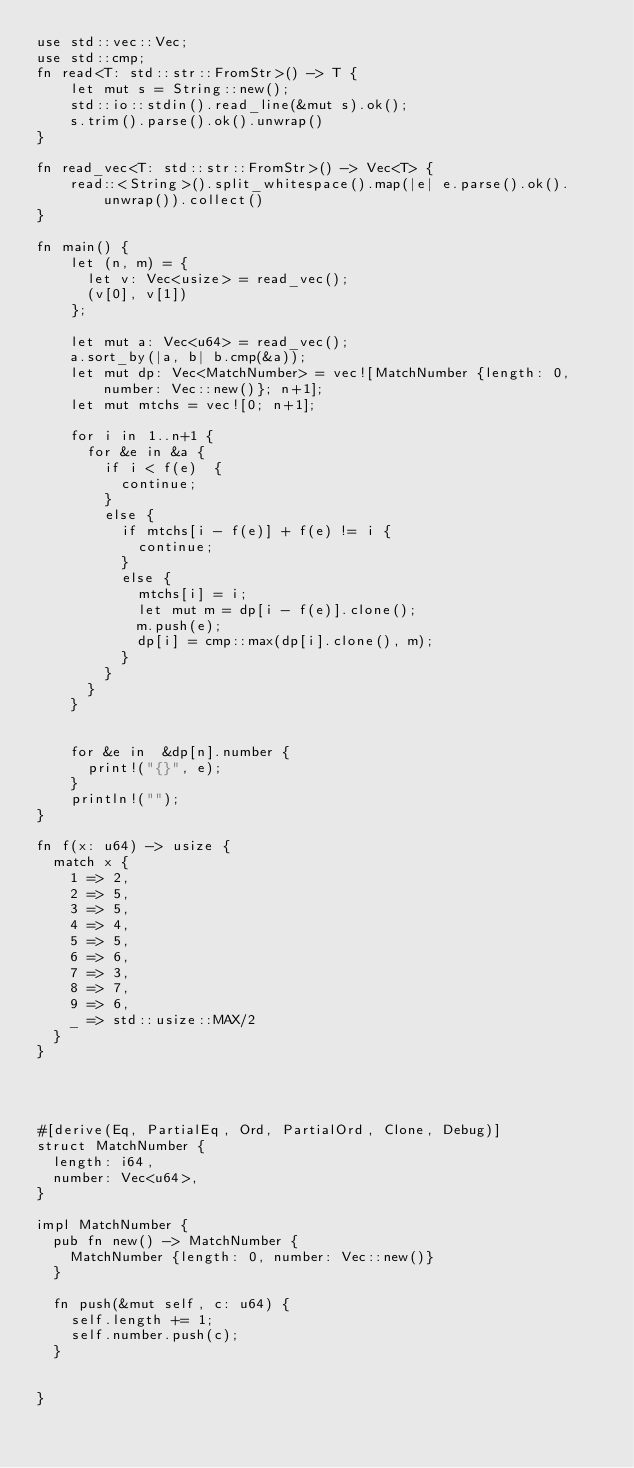<code> <loc_0><loc_0><loc_500><loc_500><_Rust_>use std::vec::Vec;
use std::cmp;
fn read<T: std::str::FromStr>() -> T {
    let mut s = String::new();
    std::io::stdin().read_line(&mut s).ok();
    s.trim().parse().ok().unwrap()
}

fn read_vec<T: std::str::FromStr>() -> Vec<T> {
    read::<String>().split_whitespace().map(|e| e.parse().ok().unwrap()).collect()
}

fn main() {
    let (n, m) = {
      let v: Vec<usize> = read_vec();
      (v[0], v[1])
    };

    let mut a: Vec<u64> = read_vec();
    a.sort_by(|a, b| b.cmp(&a));
    let mut dp: Vec<MatchNumber> = vec![MatchNumber {length: 0, number: Vec::new()}; n+1];
    let mut mtchs = vec![0; n+1];

    for i in 1..n+1 {
      for &e in &a {
        if i < f(e)  {
          continue;
        }
        else {
          if mtchs[i - f(e)] + f(e) != i {
            continue;
          }
          else {
            mtchs[i] = i;
            let mut m = dp[i - f(e)].clone();
            m.push(e);
            dp[i] = cmp::max(dp[i].clone(), m);
          }
        }
      }
    }


    for &e in  &dp[n].number {
      print!("{}", e);
    }
    println!("");
}

fn f(x: u64) -> usize {
  match x {
    1 => 2,
    2 => 5,
    3 => 5,
    4 => 4,
    5 => 5,
    6 => 6,
    7 => 3,
    8 => 7,
    9 => 6,
    _ => std::usize::MAX/2
  }
}




#[derive(Eq, PartialEq, Ord, PartialOrd, Clone, Debug)]
struct MatchNumber {
  length: i64,
  number: Vec<u64>,
}

impl MatchNumber {
  pub fn new() -> MatchNumber {
    MatchNumber {length: 0, number: Vec::new()}
  }

  fn push(&mut self, c: u64) {
    self.length += 1;
    self.number.push(c);
  }


}
</code> 